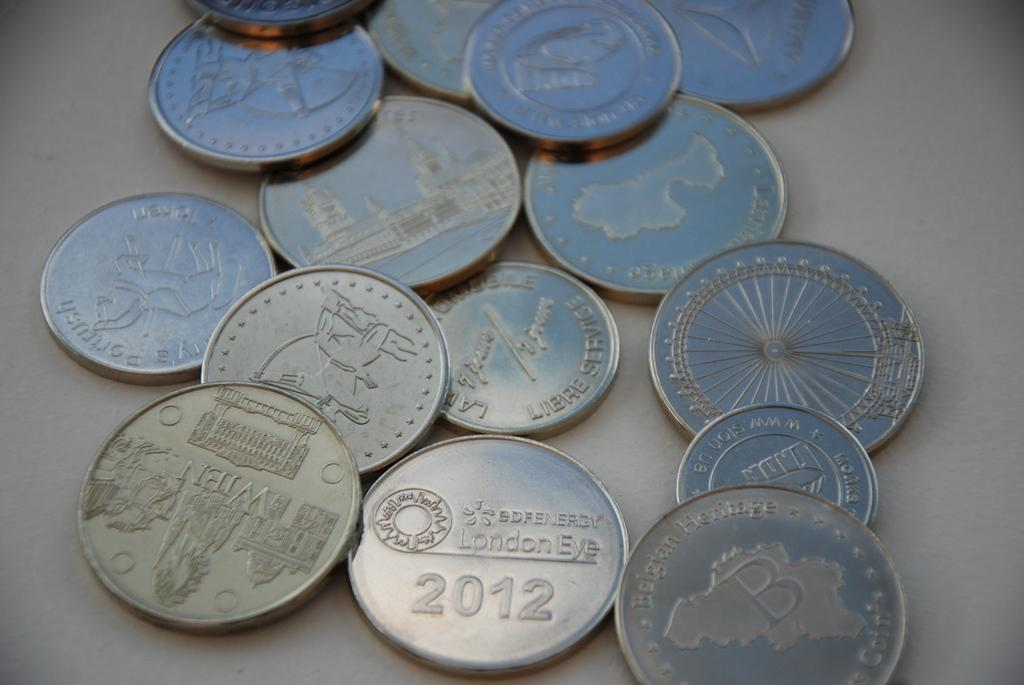Provide a one-sentence caption for the provided image. A collection of coins including one that was minted in 2012. 